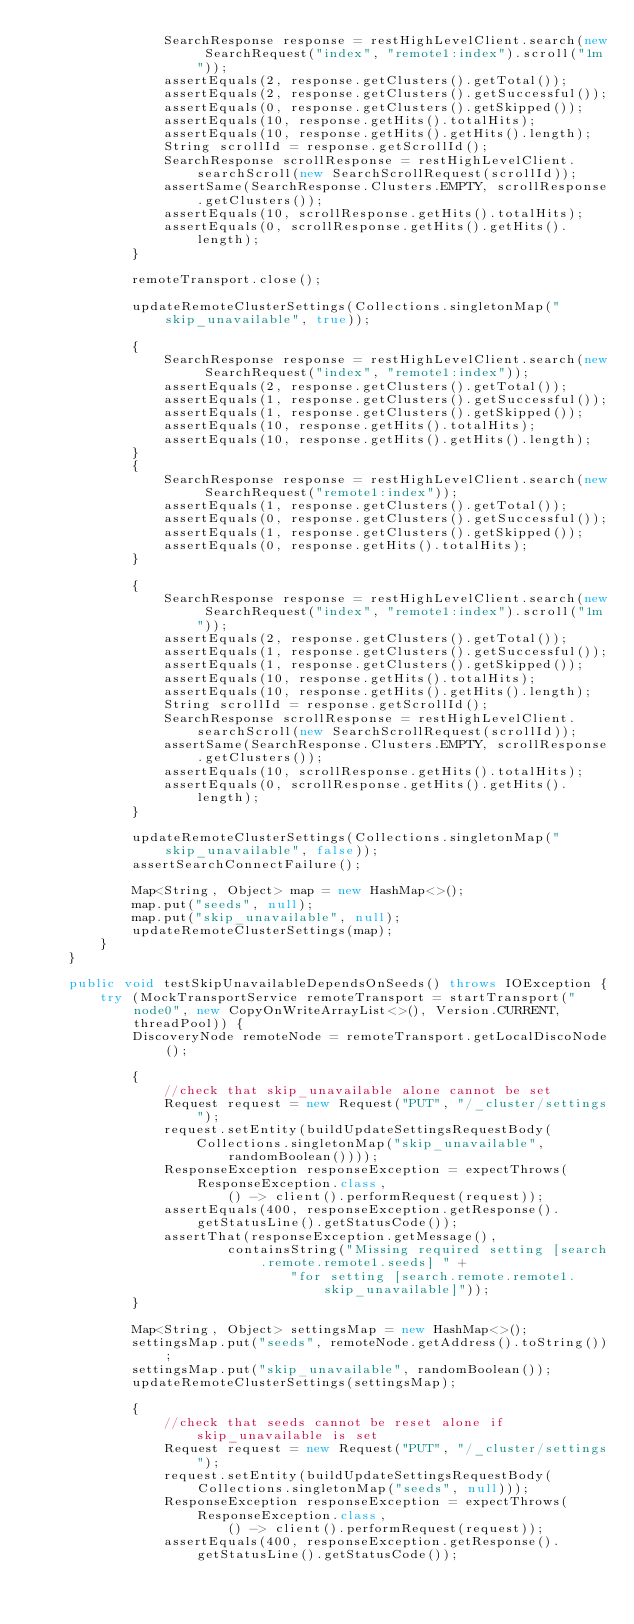Convert code to text. <code><loc_0><loc_0><loc_500><loc_500><_Java_>                SearchResponse response = restHighLevelClient.search(new SearchRequest("index", "remote1:index").scroll("1m"));
                assertEquals(2, response.getClusters().getTotal());
                assertEquals(2, response.getClusters().getSuccessful());
                assertEquals(0, response.getClusters().getSkipped());
                assertEquals(10, response.getHits().totalHits);
                assertEquals(10, response.getHits().getHits().length);
                String scrollId = response.getScrollId();
                SearchResponse scrollResponse = restHighLevelClient.searchScroll(new SearchScrollRequest(scrollId));
                assertSame(SearchResponse.Clusters.EMPTY, scrollResponse.getClusters());
                assertEquals(10, scrollResponse.getHits().totalHits);
                assertEquals(0, scrollResponse.getHits().getHits().length);
            }

            remoteTransport.close();

            updateRemoteClusterSettings(Collections.singletonMap("skip_unavailable", true));

            {
                SearchResponse response = restHighLevelClient.search(new SearchRequest("index", "remote1:index"));
                assertEquals(2, response.getClusters().getTotal());
                assertEquals(1, response.getClusters().getSuccessful());
                assertEquals(1, response.getClusters().getSkipped());
                assertEquals(10, response.getHits().totalHits);
                assertEquals(10, response.getHits().getHits().length);
            }
            {
                SearchResponse response = restHighLevelClient.search(new SearchRequest("remote1:index"));
                assertEquals(1, response.getClusters().getTotal());
                assertEquals(0, response.getClusters().getSuccessful());
                assertEquals(1, response.getClusters().getSkipped());
                assertEquals(0, response.getHits().totalHits);
            }

            {
                SearchResponse response = restHighLevelClient.search(new SearchRequest("index", "remote1:index").scroll("1m"));
                assertEquals(2, response.getClusters().getTotal());
                assertEquals(1, response.getClusters().getSuccessful());
                assertEquals(1, response.getClusters().getSkipped());
                assertEquals(10, response.getHits().totalHits);
                assertEquals(10, response.getHits().getHits().length);
                String scrollId = response.getScrollId();
                SearchResponse scrollResponse = restHighLevelClient.searchScroll(new SearchScrollRequest(scrollId));
                assertSame(SearchResponse.Clusters.EMPTY, scrollResponse.getClusters());
                assertEquals(10, scrollResponse.getHits().totalHits);
                assertEquals(0, scrollResponse.getHits().getHits().length);
            }

            updateRemoteClusterSettings(Collections.singletonMap("skip_unavailable", false));
            assertSearchConnectFailure();

            Map<String, Object> map = new HashMap<>();
            map.put("seeds", null);
            map.put("skip_unavailable", null);
            updateRemoteClusterSettings(map);
        }
    }

    public void testSkipUnavailableDependsOnSeeds() throws IOException {
        try (MockTransportService remoteTransport = startTransport("node0", new CopyOnWriteArrayList<>(), Version.CURRENT, threadPool)) {
            DiscoveryNode remoteNode = remoteTransport.getLocalDiscoNode();

            {
                //check that skip_unavailable alone cannot be set
                Request request = new Request("PUT", "/_cluster/settings");
                request.setEntity(buildUpdateSettingsRequestBody(
                    Collections.singletonMap("skip_unavailable", randomBoolean())));
                ResponseException responseException = expectThrows(ResponseException.class,
                        () -> client().performRequest(request));
                assertEquals(400, responseException.getResponse().getStatusLine().getStatusCode());
                assertThat(responseException.getMessage(),
                        containsString("Missing required setting [search.remote.remote1.seeds] " +
                                "for setting [search.remote.remote1.skip_unavailable]"));
            }

            Map<String, Object> settingsMap = new HashMap<>();
            settingsMap.put("seeds", remoteNode.getAddress().toString());
            settingsMap.put("skip_unavailable", randomBoolean());
            updateRemoteClusterSettings(settingsMap);

            {
                //check that seeds cannot be reset alone if skip_unavailable is set
                Request request = new Request("PUT", "/_cluster/settings");
                request.setEntity(buildUpdateSettingsRequestBody(Collections.singletonMap("seeds", null)));
                ResponseException responseException = expectThrows(ResponseException.class,
                        () -> client().performRequest(request));
                assertEquals(400, responseException.getResponse().getStatusLine().getStatusCode());</code> 